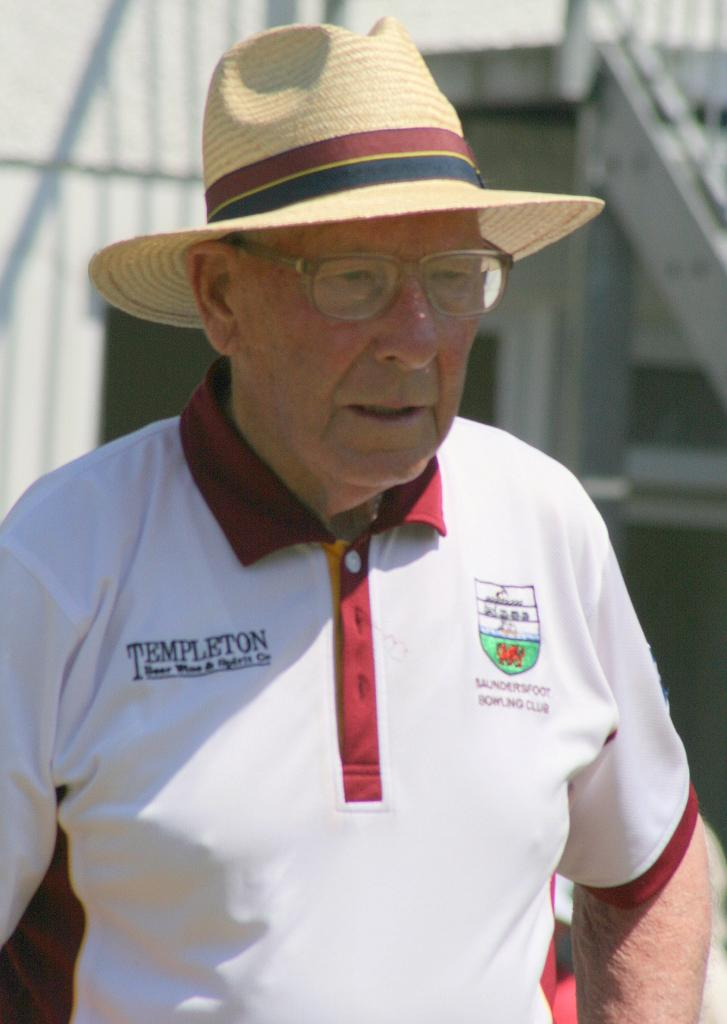<image>
Render a clear and concise summary of the photo. A man in a straw hat has the word Templeton on his white collared shirt. 